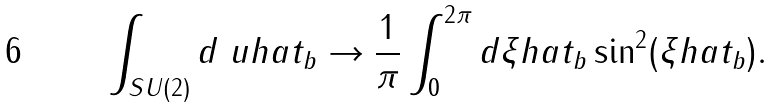Convert formula to latex. <formula><loc_0><loc_0><loc_500><loc_500>\int _ { S U ( 2 ) } d \ u h a t _ { b } \rightarrow \frac { 1 } { \pi } \int _ { 0 } ^ { 2 \pi } d \xi h a t _ { b } \sin ^ { 2 } ( \xi h a t _ { b } ) .</formula> 